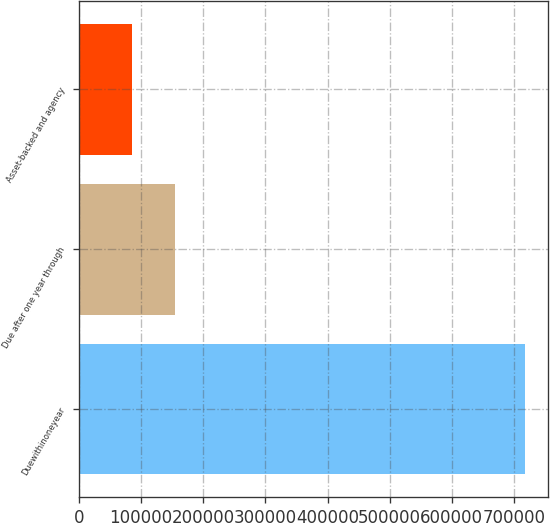Convert chart to OTSL. <chart><loc_0><loc_0><loc_500><loc_500><bar_chart><fcel>Duewithinoneyear<fcel>Due after one year through<fcel>Asset-backed and agency<nl><fcel>717979<fcel>155252<fcel>85692<nl></chart> 